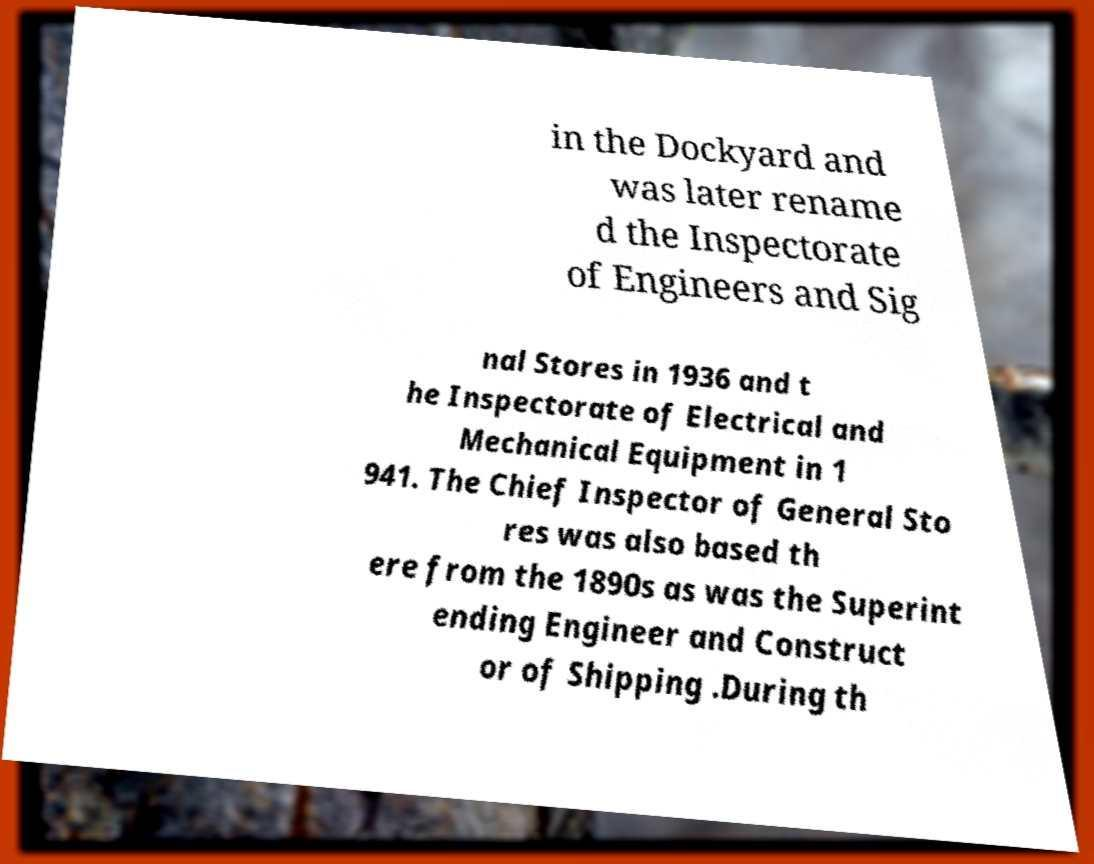Can you accurately transcribe the text from the provided image for me? in the Dockyard and was later rename d the Inspectorate of Engineers and Sig nal Stores in 1936 and t he Inspectorate of Electrical and Mechanical Equipment in 1 941. The Chief Inspector of General Sto res was also based th ere from the 1890s as was the Superint ending Engineer and Construct or of Shipping .During th 